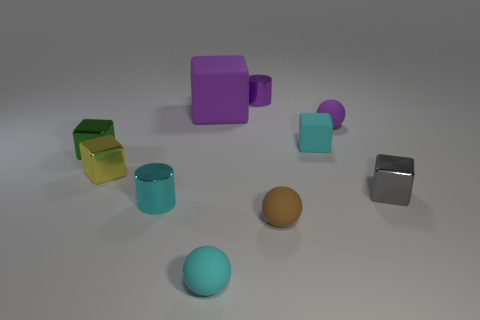What material is the small gray thing that is the same shape as the yellow thing?
Provide a short and direct response. Metal. There is a cylinder that is the same color as the large block; what is it made of?
Give a very brief answer. Metal. Is the number of small cyan cylinders less than the number of large gray cylinders?
Your answer should be very brief. No. Do the metallic object that is in front of the small gray metallic thing and the big thing have the same color?
Provide a short and direct response. No. There is a tiny block that is the same material as the big purple cube; what is its color?
Your answer should be compact. Cyan. Do the brown rubber object and the purple rubber cube have the same size?
Keep it short and to the point. No. What material is the brown ball?
Ensure brevity in your answer.  Rubber. What material is the cyan sphere that is the same size as the yellow metallic cube?
Ensure brevity in your answer.  Rubber. Are there any brown metal cubes that have the same size as the gray metal object?
Offer a terse response. No. Is the number of tiny green metallic things that are right of the tiny purple matte object the same as the number of small gray things that are in front of the cyan matte ball?
Offer a terse response. Yes. 